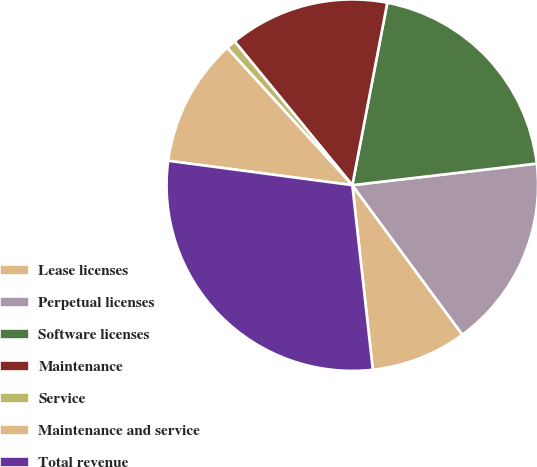<chart> <loc_0><loc_0><loc_500><loc_500><pie_chart><fcel>Lease licenses<fcel>Perpetual licenses<fcel>Software licenses<fcel>Maintenance<fcel>Service<fcel>Maintenance and service<fcel>Total revenue<nl><fcel>8.34%<fcel>16.75%<fcel>20.13%<fcel>13.94%<fcel>0.84%<fcel>11.14%<fcel>28.86%<nl></chart> 